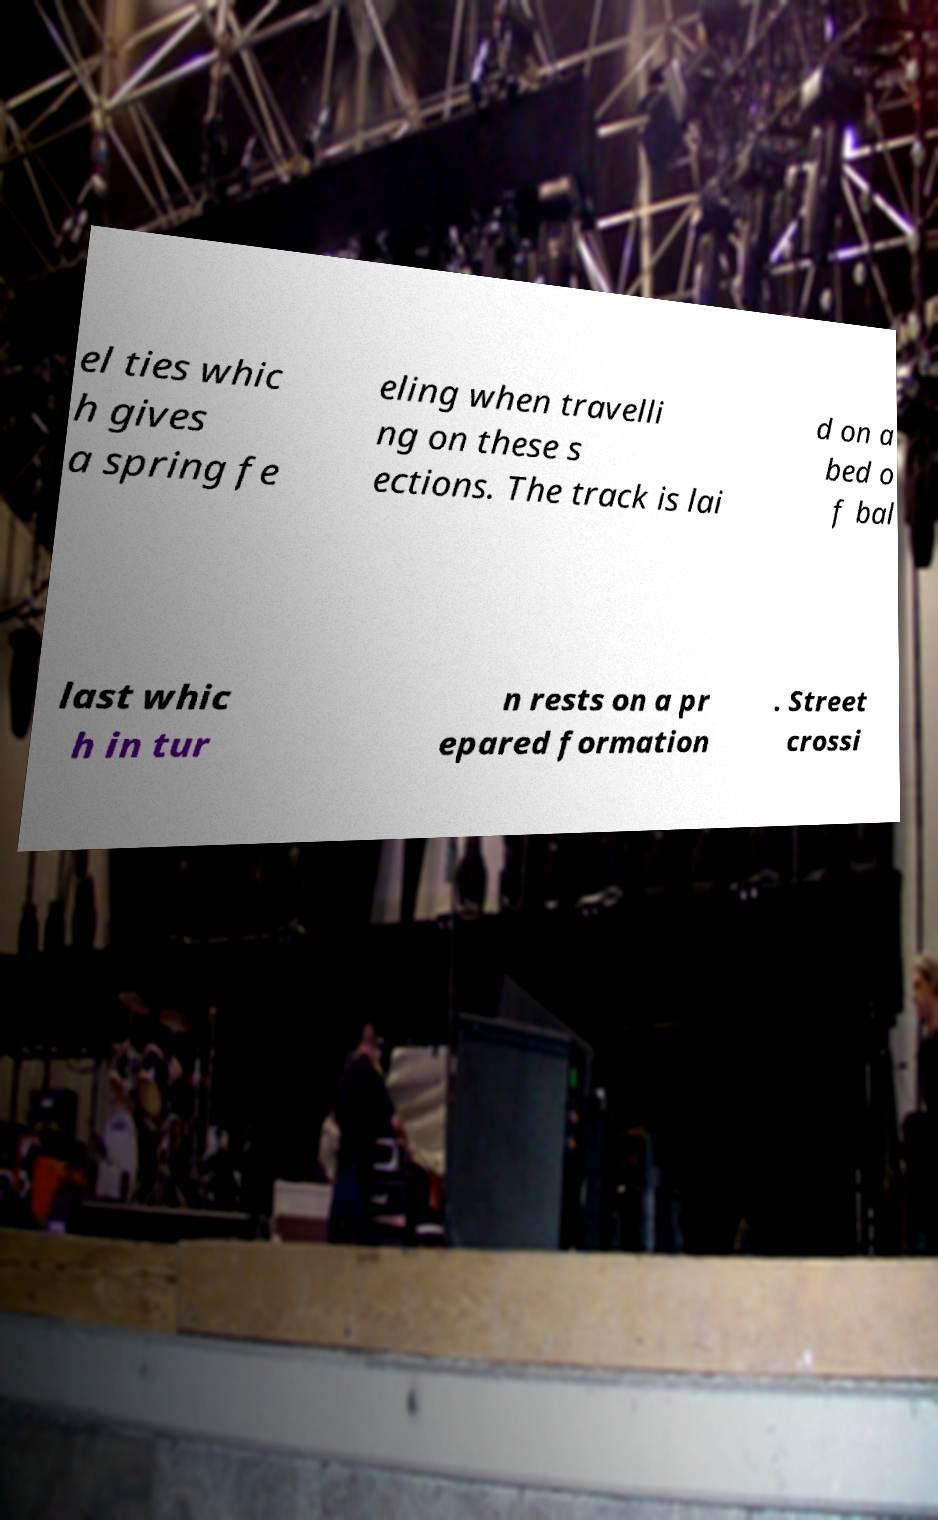Please read and relay the text visible in this image. What does it say? el ties whic h gives a spring fe eling when travelli ng on these s ections. The track is lai d on a bed o f bal last whic h in tur n rests on a pr epared formation . Street crossi 